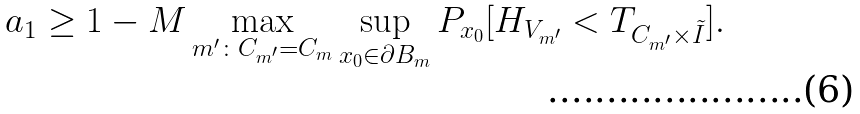Convert formula to latex. <formula><loc_0><loc_0><loc_500><loc_500>a _ { 1 } \geq 1 - M \max _ { m ^ { \prime } \colon C _ { m ^ { \prime } } = C _ { m } } \sup _ { x _ { 0 } \in \partial B _ { m } } P _ { x _ { 0 } } [ H _ { V _ { m ^ { \prime } } } < T _ { C _ { m ^ { \prime } } \times { \tilde { I } } } ] .</formula> 